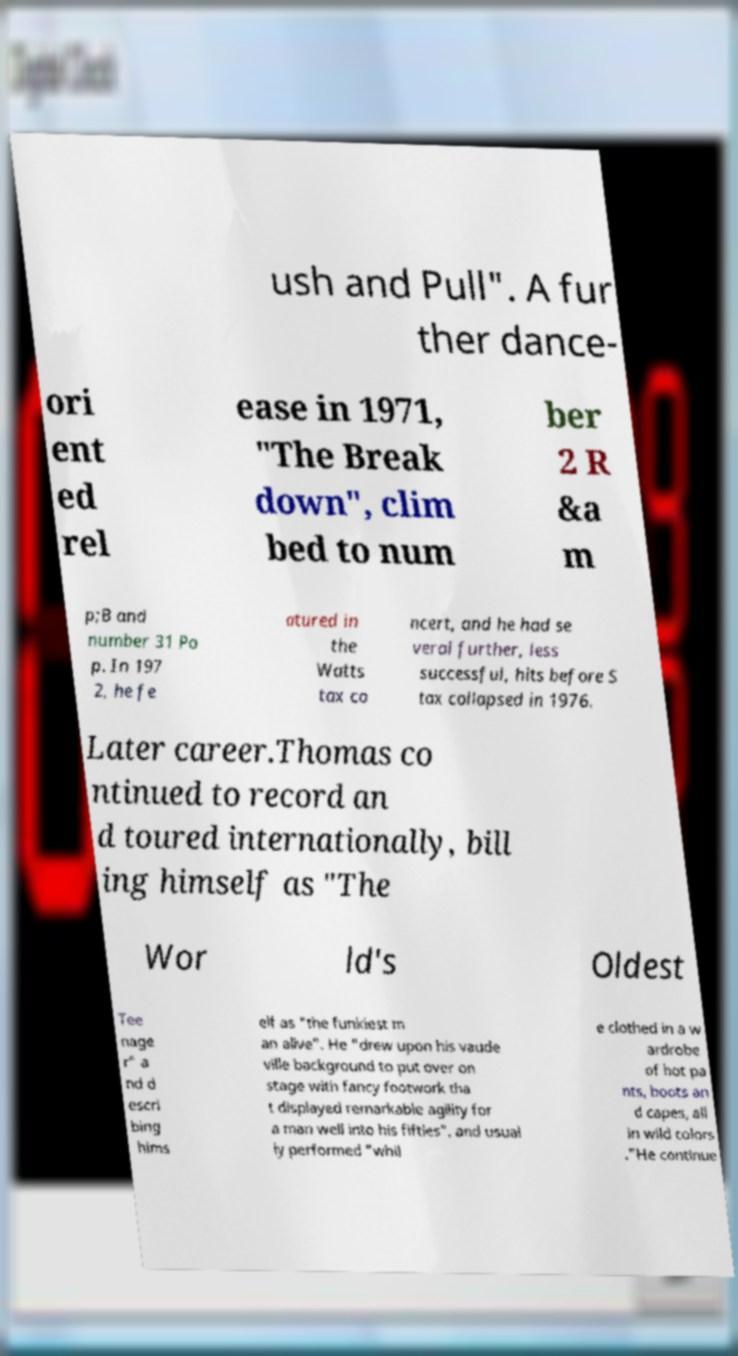Please identify and transcribe the text found in this image. ush and Pull". A fur ther dance- ori ent ed rel ease in 1971, "The Break down", clim bed to num ber 2 R &a m p;B and number 31 Po p. In 197 2, he fe atured in the Watts tax co ncert, and he had se veral further, less successful, hits before S tax collapsed in 1976. Later career.Thomas co ntinued to record an d toured internationally, bill ing himself as "The Wor ld's Oldest Tee nage r" a nd d escri bing hims elf as "the funkiest m an alive". He "drew upon his vaude ville background to put over on stage with fancy footwork tha t displayed remarkable agility for a man well into his fifties", and usual ly performed "whil e clothed in a w ardrobe of hot pa nts, boots an d capes, all in wild colors ."He continue 